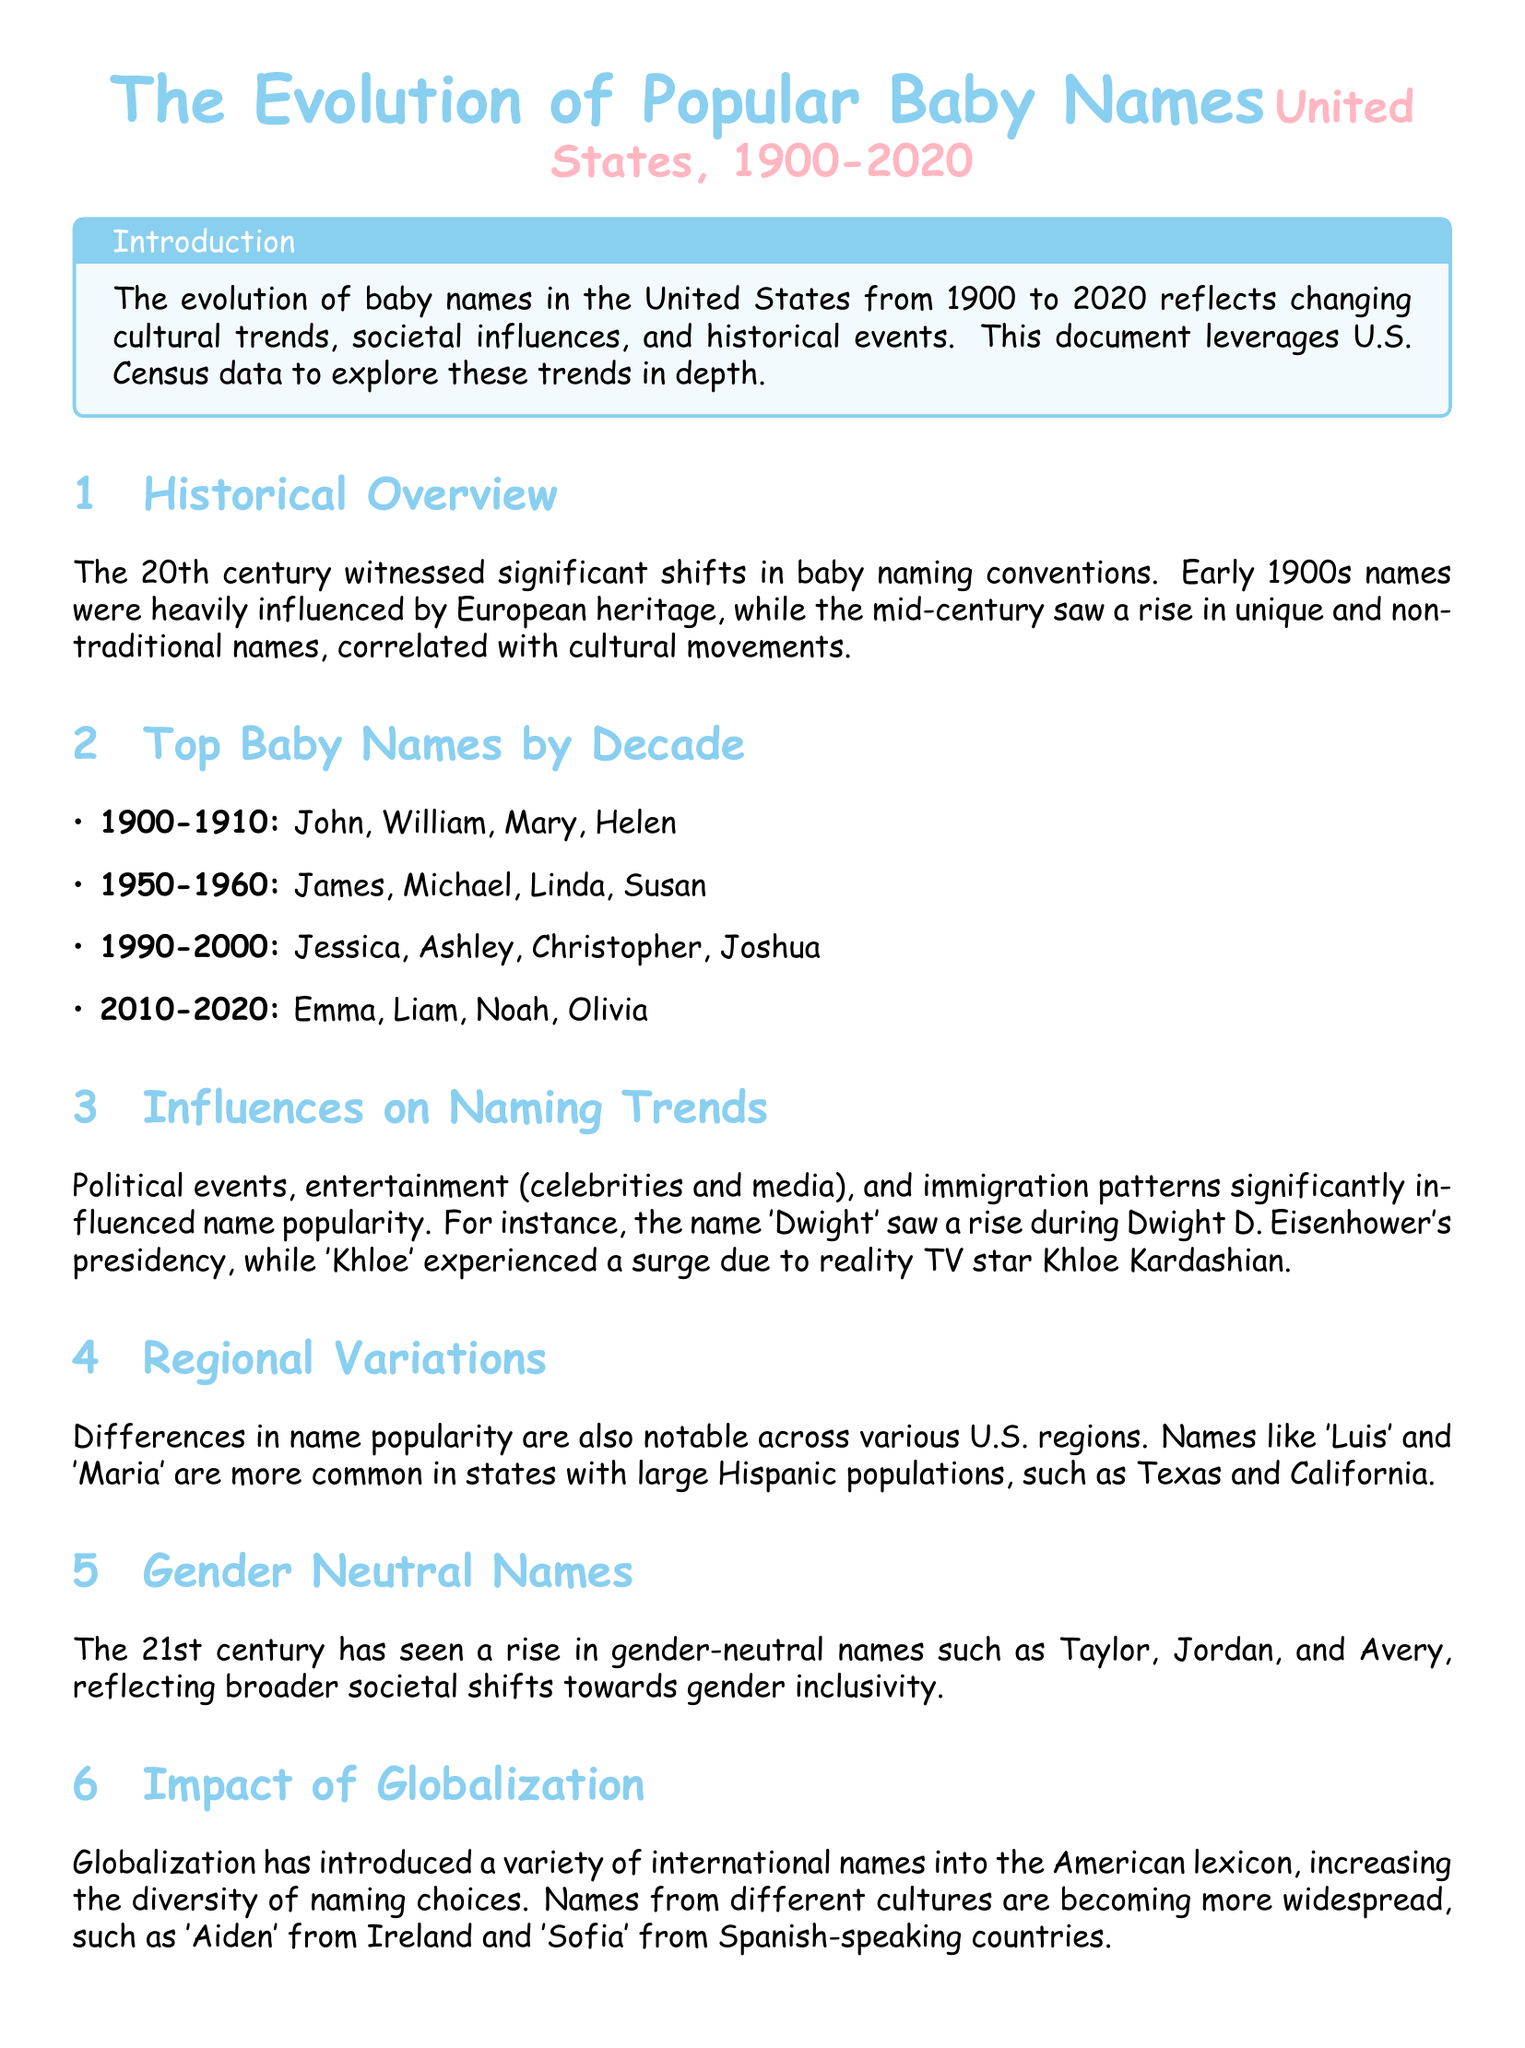what were the top baby names from 1900-1910? The document lists the top baby names for the decade 1900-1910 as John, William, Mary, Helen.
Answer: John, William, Mary, Helen which name became popular due to Dwight D. Eisenhower? The document states that the name 'Dwight' saw a rise during Dwight D. Eisenhower's presidency.
Answer: Dwight what is a notable trend in baby names in the 21st century? The document highlights that the 21st century has seen a rise in gender-neutral names reflecting societal shifts.
Answer: Gender-neutral names what were the top baby names from 2010-2020? The document lists the top baby names for the decade 2010-2020 as Emma, Liam, Noah, Olivia.
Answer: Emma, Liam, Noah, Olivia which two names are associated with states with large Hispanic populations? The document mentions that names like 'Luis' and 'Maria' are more common in states with large Hispanic populations.
Answer: Luis, Maria how did globalization affect naming conventions? The document explains that globalization introduced a variety of international names into the American lexicon, increasing naming diversity.
Answer: Increased diversity what influenced the rise of the name 'Khloe'? The document states that 'Khloe' experienced a surge due to reality TV star Khloe Kardashian.
Answer: Khloe Kardashian which decade saw a rise in names like Jessica and Ashley? The document lists the top baby names for the decade 1990-2000 that included Jessica and Ashley.
Answer: 1990-2000 what is one effect of cultural movements on baby names? The document indicates that cultural movements led to a rise in unique and non-traditional names in the mid-century.
Answer: Unique and non-traditional names 